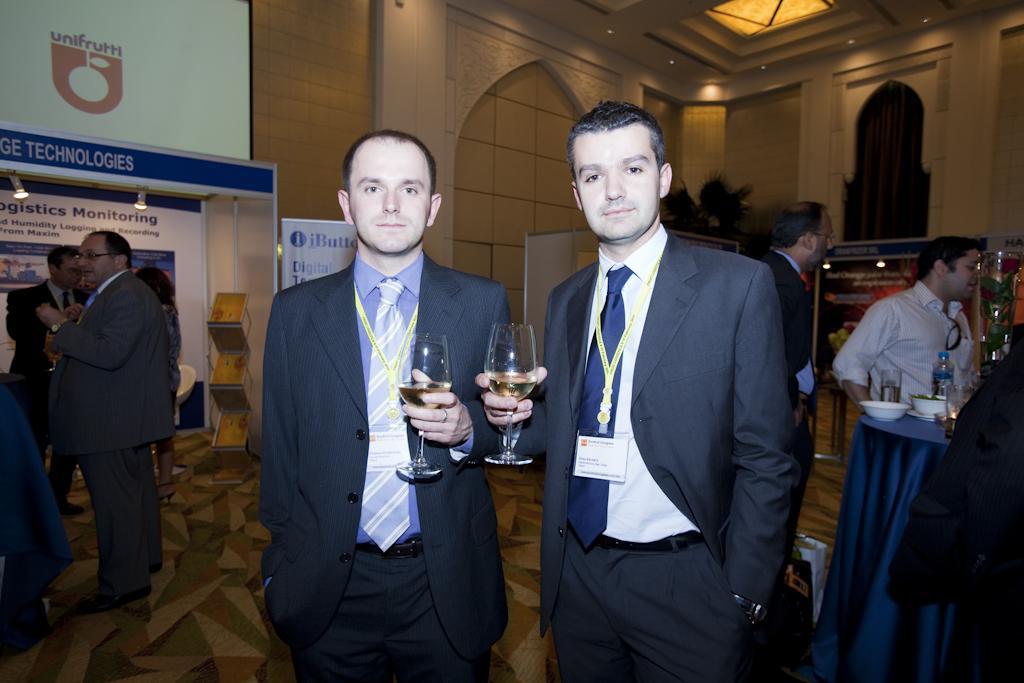How would you summarize this image in a sentence or two? In this image we can see a group of people standing on the floor. Two men are holding glasses in their hands. On the left side of the image we can see some birds, a chair placed on the ground, we can also see banners with some text and a screen on the wall. On the right side of the image we can see cups, bottle and some flowers in a container placed on the table. In the background, we can see plants and some lights on the roof. 